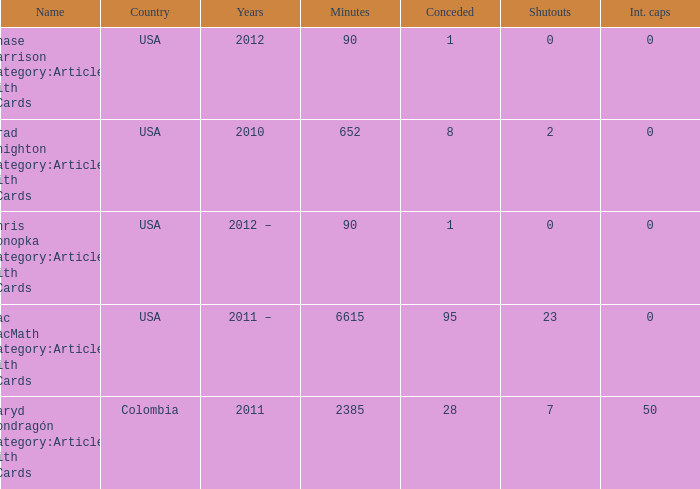What is the lowest overall amount of shutouts? 0.0. 